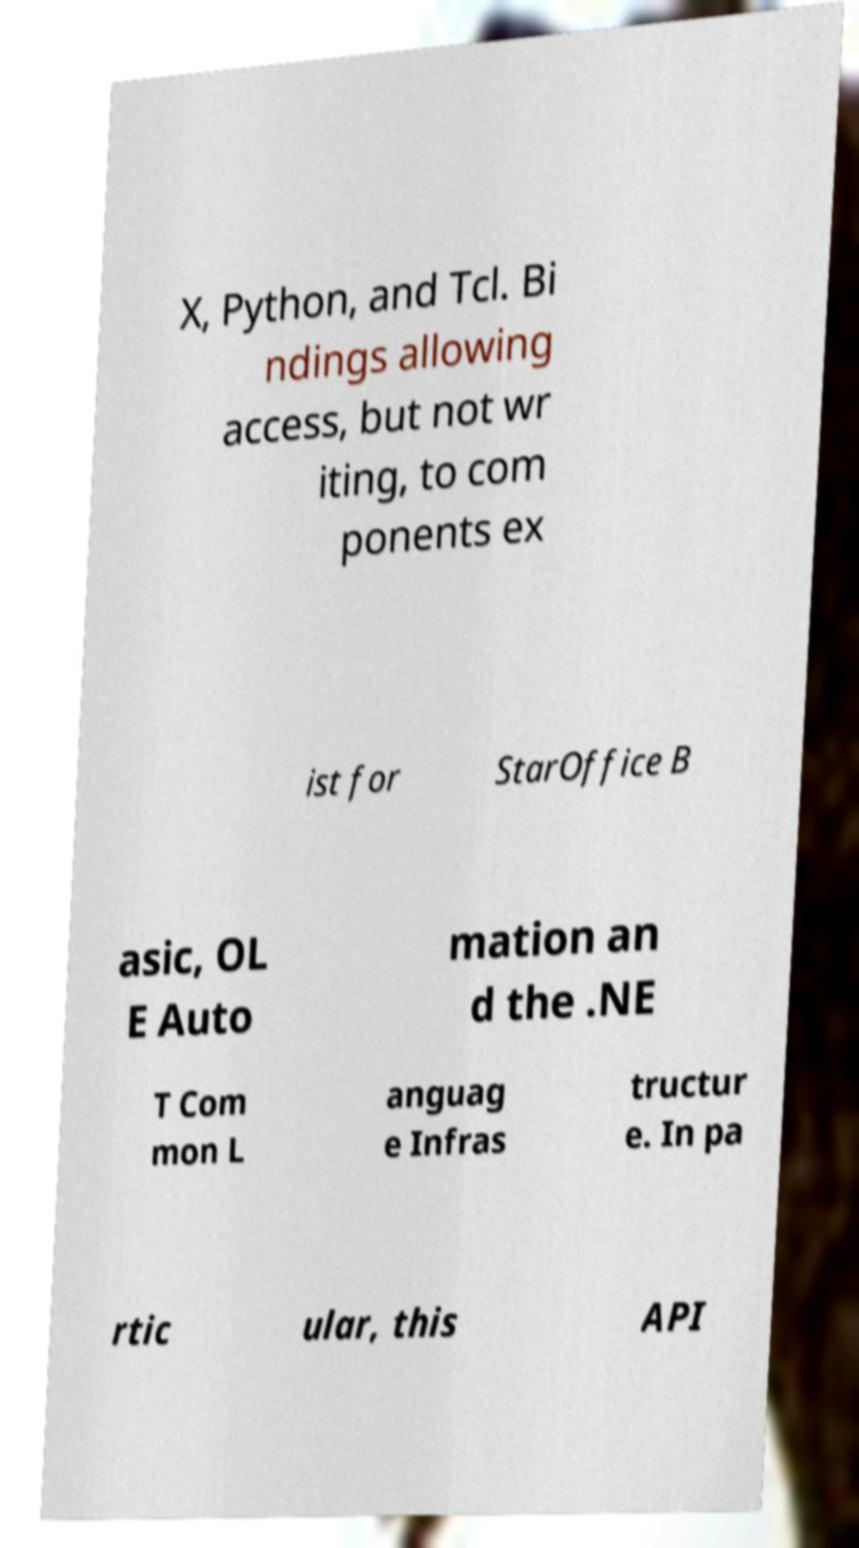Can you read and provide the text displayed in the image?This photo seems to have some interesting text. Can you extract and type it out for me? X, Python, and Tcl. Bi ndings allowing access, but not wr iting, to com ponents ex ist for StarOffice B asic, OL E Auto mation an d the .NE T Com mon L anguag e Infras tructur e. In pa rtic ular, this API 